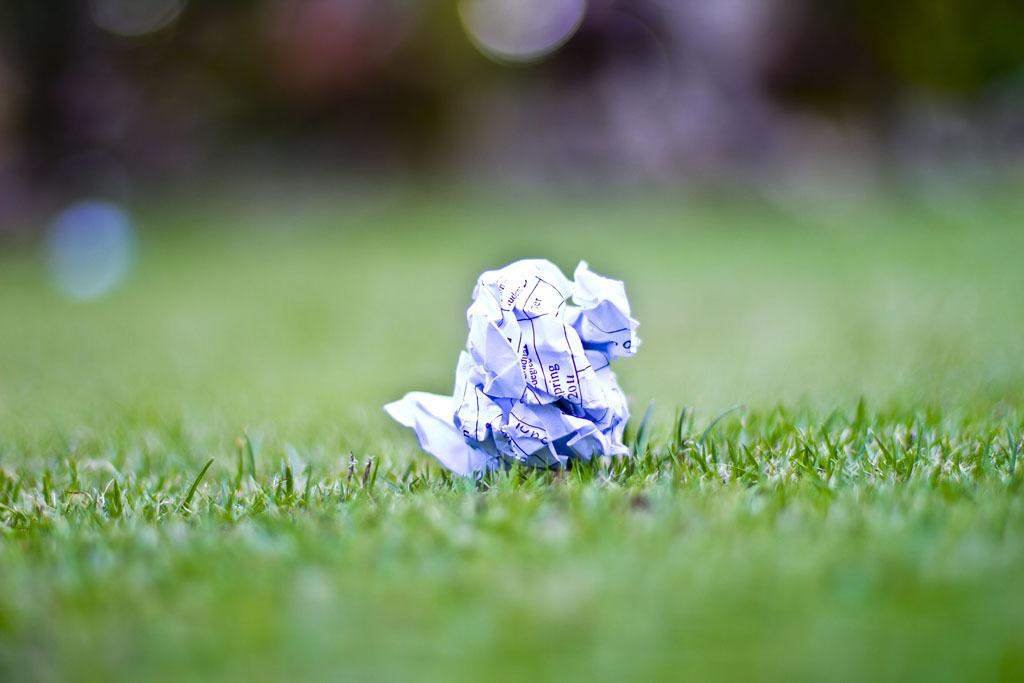What is located in the garden in the image? There is a paper in the garden. Can you see an airplane flying over the garden in the image? There is no mention of an airplane in the image, so it cannot be determined if one is present. Is the paper in the garden being kicked around in the image? There is no indication in the image that the paper is being kicked around. 